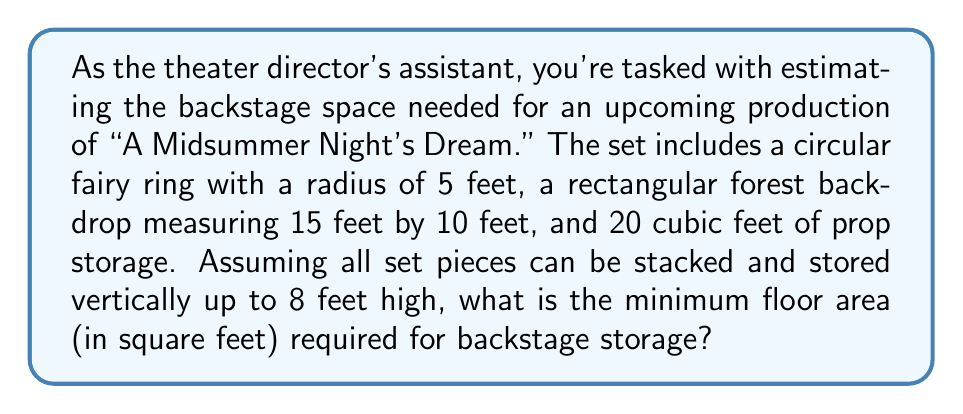Help me with this question. Let's approach this step-by-step, keeping in mind our love for the theater and the director's vision:

1) First, let's calculate the area of the fairy ring:
   Area of a circle = $\pi r^2$
   $A_{fairy} = \pi \cdot 5^2 = 25\pi \approx 78.54$ sq ft

2) Now, the area of the forest backdrop:
   $A_{backdrop} = 15 \cdot 10 = 150$ sq ft

3) For the props, we're given a volume. To convert this to area, we'll use the maximum height:
   $A_{props} = \frac{20\text{ cubic feet}}{8\text{ feet}} = 2.5$ sq ft

4) Now, let's sum up all the areas:
   $A_{total} = A_{fairy} + A_{backdrop} + A_{props}$
   $A_{total} = 78.54 + 150 + 2.5 = 231.04$ sq ft

5) However, we need to account for some maneuvering space. Let's add a 20% buffer:
   $A_{final} = A_{total} \cdot 1.2 = 231.04 \cdot 1.2 = 277.25$ sq ft

6) Rounding up to the nearest square foot for practicality:
   $A_{final} \approx 278$ sq ft
Answer: 278 sq ft 